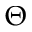<formula> <loc_0><loc_0><loc_500><loc_500>\Theta</formula> 